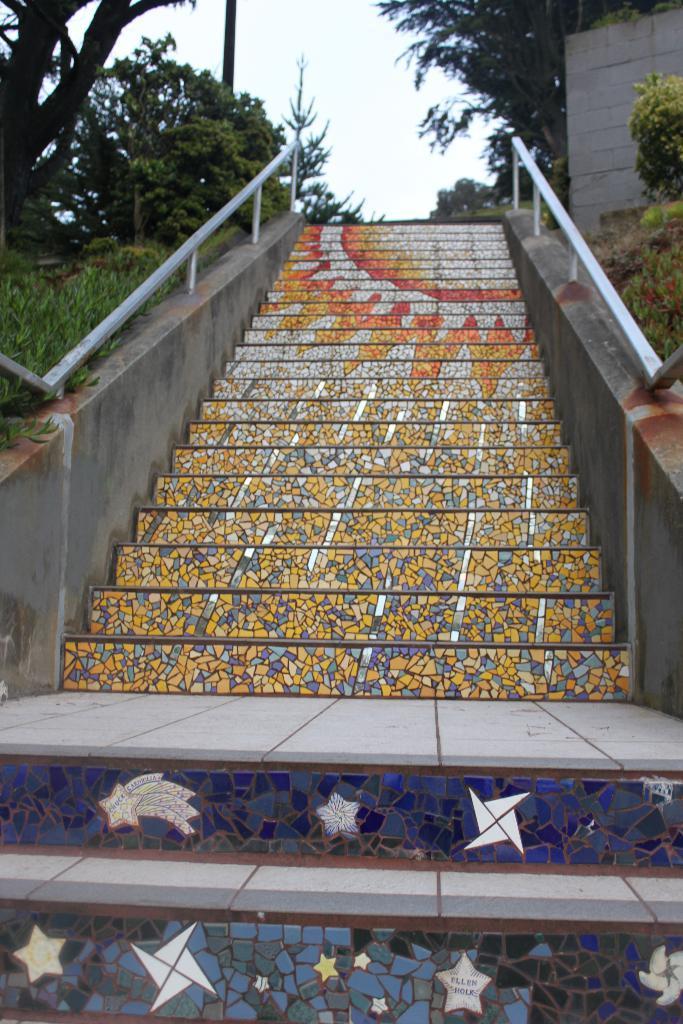Can you describe this image briefly? In this image I can see the stairs. On the both sides of the stairs I can see the railing and also few plants. In the background there are some trees. On the right side I can see a wall. At the top I can see the sky. 